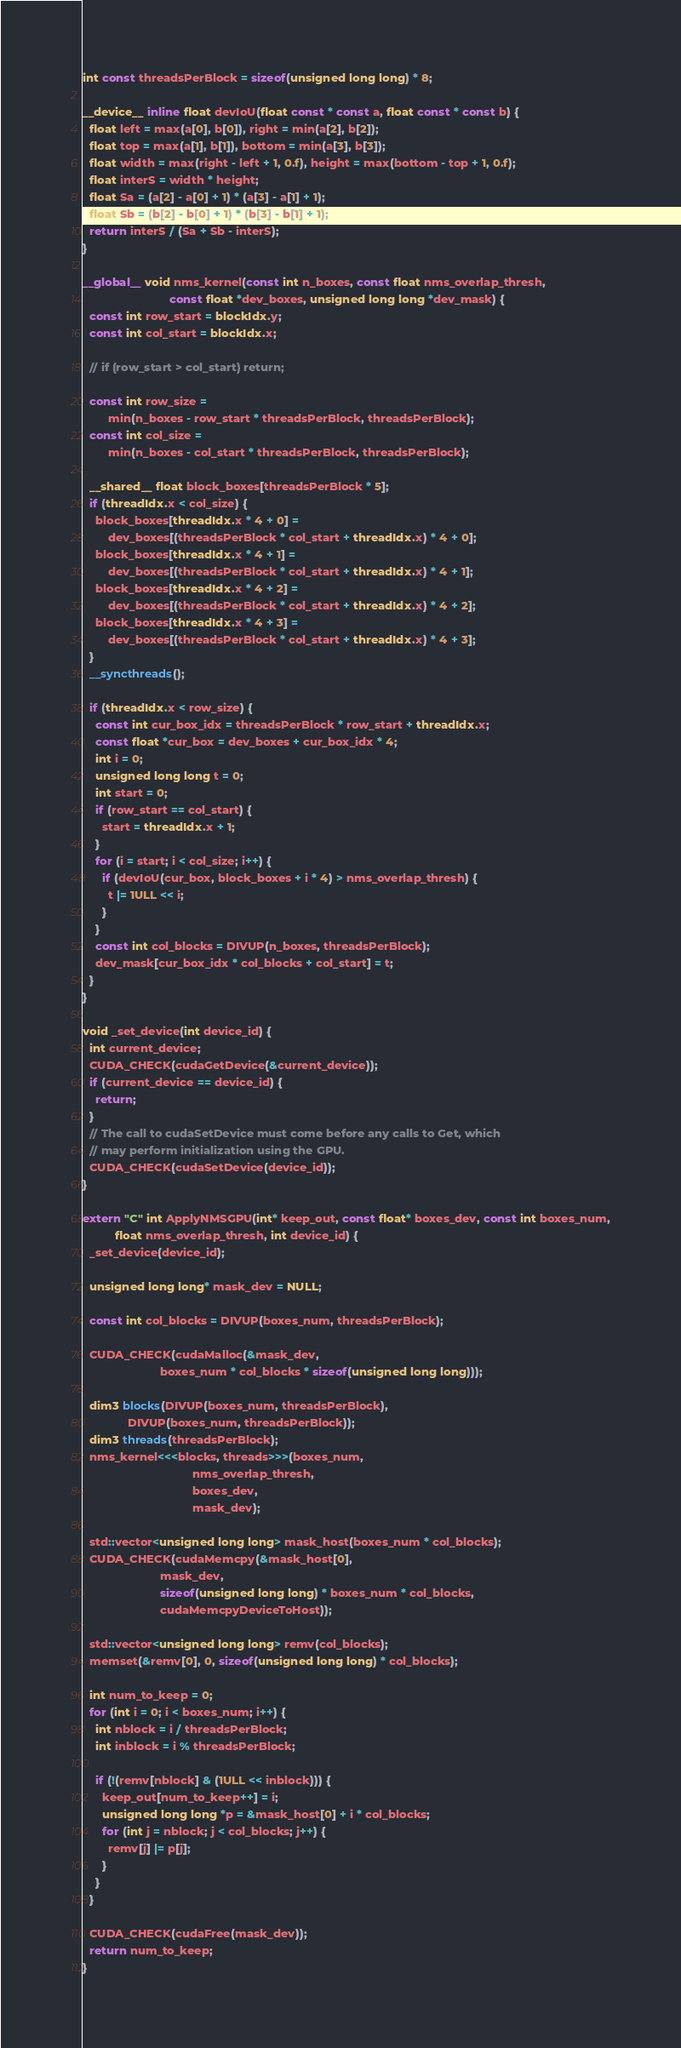Convert code to text. <code><loc_0><loc_0><loc_500><loc_500><_Cuda_>int const threadsPerBlock = sizeof(unsigned long long) * 8;

__device__ inline float devIoU(float const * const a, float const * const b) {
  float left = max(a[0], b[0]), right = min(a[2], b[2]);
  float top = max(a[1], b[1]), bottom = min(a[3], b[3]);
  float width = max(right - left + 1, 0.f), height = max(bottom - top + 1, 0.f);
  float interS = width * height;
  float Sa = (a[2] - a[0] + 1) * (a[3] - a[1] + 1);
  float Sb = (b[2] - b[0] + 1) * (b[3] - b[1] + 1);
  return interS / (Sa + Sb - interS);
}

__global__ void nms_kernel(const int n_boxes, const float nms_overlap_thresh,
                           const float *dev_boxes, unsigned long long *dev_mask) {
  const int row_start = blockIdx.y;
  const int col_start = blockIdx.x;

  // if (row_start > col_start) return;

  const int row_size =
        min(n_boxes - row_start * threadsPerBlock, threadsPerBlock);
  const int col_size =
        min(n_boxes - col_start * threadsPerBlock, threadsPerBlock);

  __shared__ float block_boxes[threadsPerBlock * 5];
  if (threadIdx.x < col_size) {
    block_boxes[threadIdx.x * 4 + 0] =
        dev_boxes[(threadsPerBlock * col_start + threadIdx.x) * 4 + 0];
    block_boxes[threadIdx.x * 4 + 1] =
        dev_boxes[(threadsPerBlock * col_start + threadIdx.x) * 4 + 1];
    block_boxes[threadIdx.x * 4 + 2] =
        dev_boxes[(threadsPerBlock * col_start + threadIdx.x) * 4 + 2];
    block_boxes[threadIdx.x * 4 + 3] =
        dev_boxes[(threadsPerBlock * col_start + threadIdx.x) * 4 + 3];
  }
  __syncthreads();

  if (threadIdx.x < row_size) {
    const int cur_box_idx = threadsPerBlock * row_start + threadIdx.x;
    const float *cur_box = dev_boxes + cur_box_idx * 4;
    int i = 0;
    unsigned long long t = 0;
    int start = 0;
    if (row_start == col_start) {
      start = threadIdx.x + 1;
    }
    for (i = start; i < col_size; i++) {
      if (devIoU(cur_box, block_boxes + i * 4) > nms_overlap_thresh) {
        t |= 1ULL << i;
      }
    }
    const int col_blocks = DIVUP(n_boxes, threadsPerBlock);
    dev_mask[cur_box_idx * col_blocks + col_start] = t;
  }
}

void _set_device(int device_id) {
  int current_device;
  CUDA_CHECK(cudaGetDevice(&current_device));
  if (current_device == device_id) {
    return;
  }
  // The call to cudaSetDevice must come before any calls to Get, which
  // may perform initialization using the GPU.
  CUDA_CHECK(cudaSetDevice(device_id));
}

extern "C" int ApplyNMSGPU(int* keep_out, const float* boxes_dev, const int boxes_num,
          float nms_overlap_thresh, int device_id) {
  _set_device(device_id);

  unsigned long long* mask_dev = NULL;

  const int col_blocks = DIVUP(boxes_num, threadsPerBlock);

  CUDA_CHECK(cudaMalloc(&mask_dev,
                        boxes_num * col_blocks * sizeof(unsigned long long)));

  dim3 blocks(DIVUP(boxes_num, threadsPerBlock),
              DIVUP(boxes_num, threadsPerBlock));
  dim3 threads(threadsPerBlock);
  nms_kernel<<<blocks, threads>>>(boxes_num,
                                  nms_overlap_thresh,
                                  boxes_dev,
                                  mask_dev);

  std::vector<unsigned long long> mask_host(boxes_num * col_blocks);
  CUDA_CHECK(cudaMemcpy(&mask_host[0],
                        mask_dev,
                        sizeof(unsigned long long) * boxes_num * col_blocks,
                        cudaMemcpyDeviceToHost));

  std::vector<unsigned long long> remv(col_blocks);
  memset(&remv[0], 0, sizeof(unsigned long long) * col_blocks);

  int num_to_keep = 0;
  for (int i = 0; i < boxes_num; i++) {
    int nblock = i / threadsPerBlock;
    int inblock = i % threadsPerBlock;

    if (!(remv[nblock] & (1ULL << inblock))) {
      keep_out[num_to_keep++] = i;
      unsigned long long *p = &mask_host[0] + i * col_blocks;
      for (int j = nblock; j < col_blocks; j++) {
        remv[j] |= p[j];
      }
    }
  }

  CUDA_CHECK(cudaFree(mask_dev));
  return num_to_keep;
}
</code> 